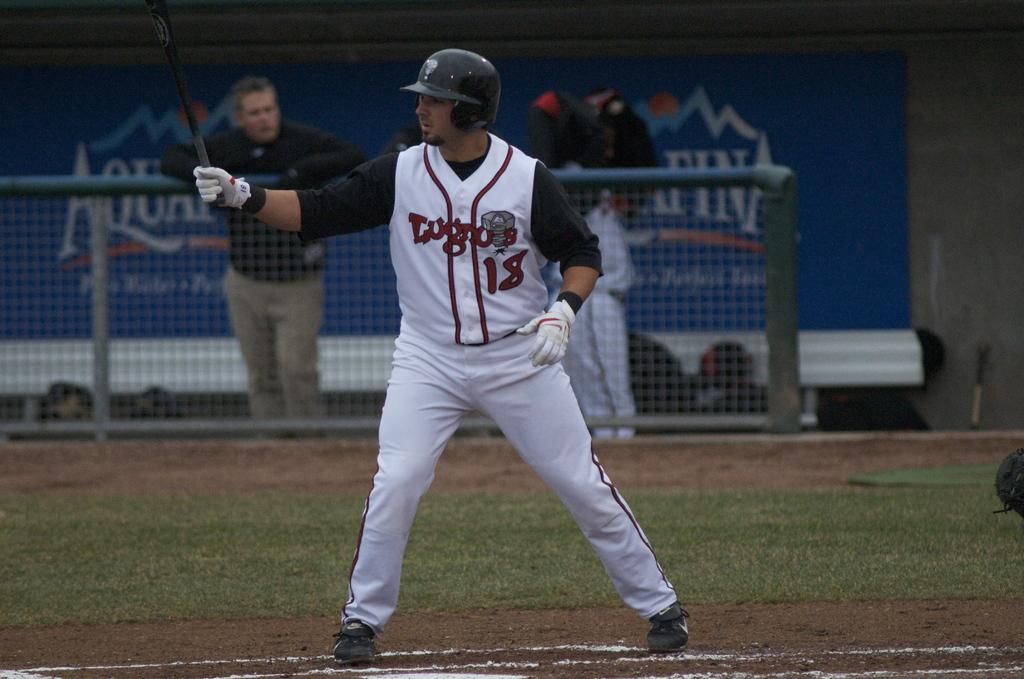<image>
Provide a brief description of the given image. A sports player has the number 18 in red on his shirt. 